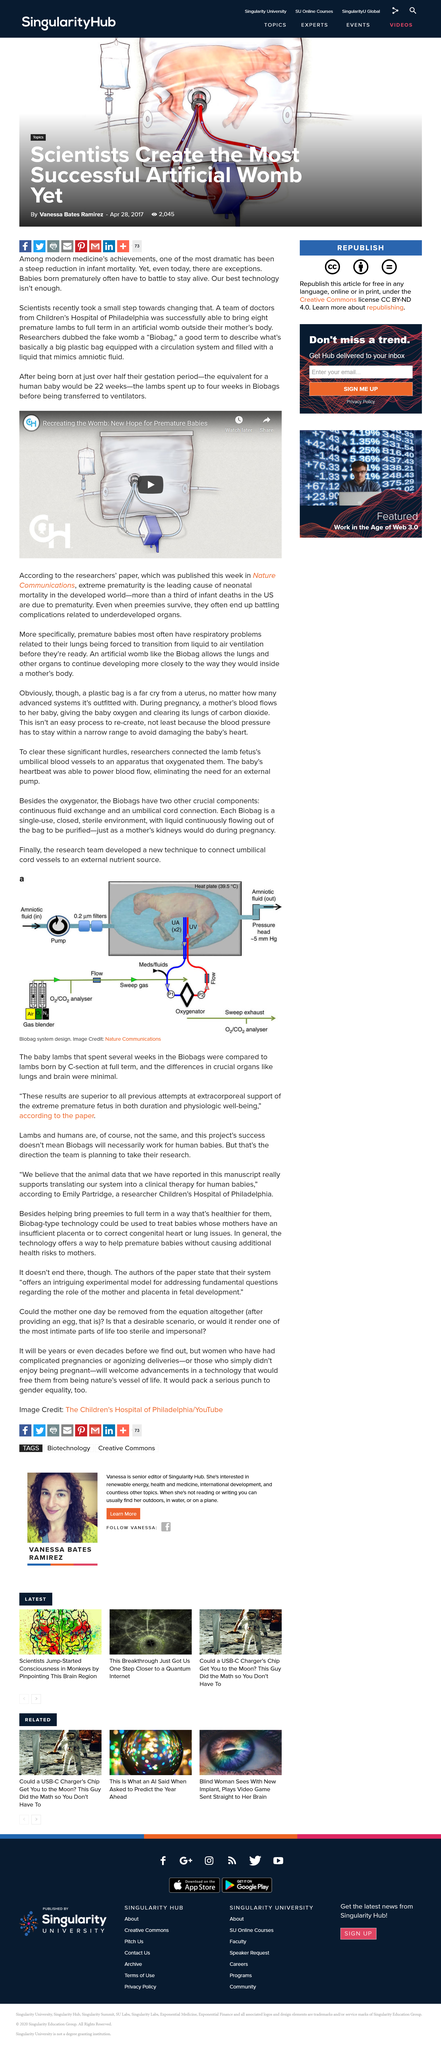Outline some significant characteristics in this image. The temperature in the heat place is 39.5 degrees Celsius. Lambs were housed in Biobags for four weeks prior to being transferred to ventilators. The Biobag consists of three crucial components: the oxygenator, which facilitates oxygen exchange; the continuous fluid exchange system, which maintains a sterile environment; and the umbilical cord connection, which provides vital nutrients and waste removal. Yes, modern medical technology has effectively contributed to a reduction in infant mortality rates. The fluid that constantly flows out of the bag to be purified, simulating a mother's kidneys during pregnancy, is amniotic fluid. 